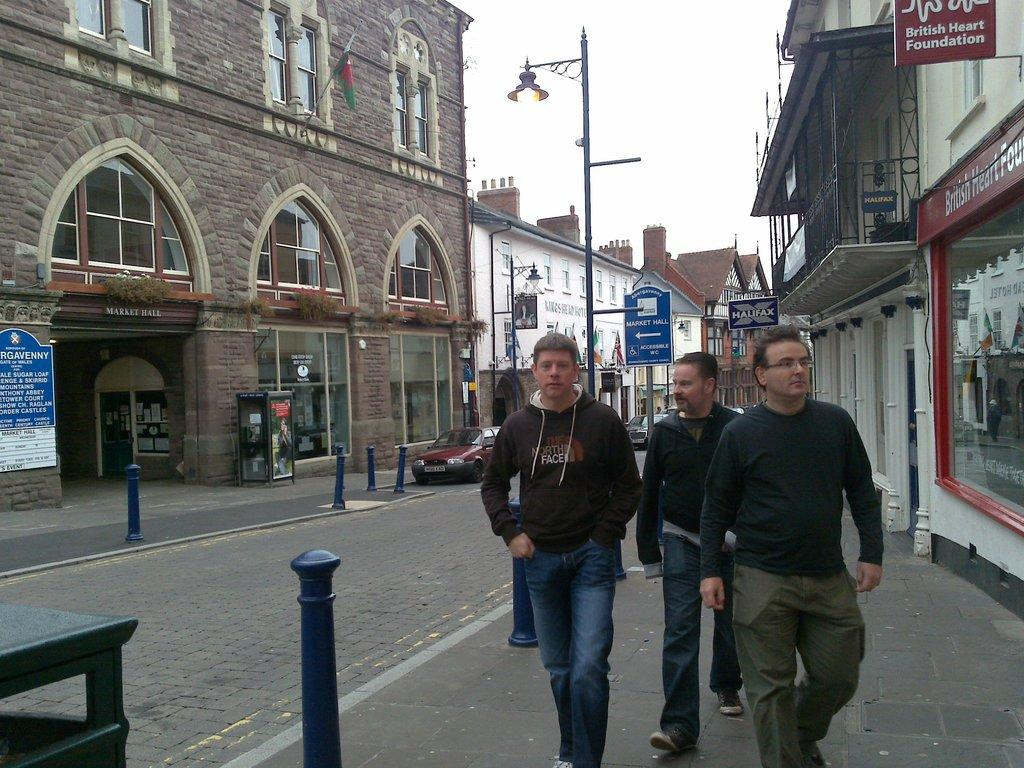What type of structures can be seen in the image? There are buildings with windows in the image. What objects are visible near the buildings? Boards and light poles are present in the image. What are the people in the image doing? People are walking on a footpath in the image. What can be seen in the background of the image? Vehicles are visible in the background of the image. What symbol is present in the image? There is a flag in the image. What type of winter clothing can be seen on the people in the image? There is no mention of winter or clothing in the image; people are simply walking on a footpath. What show is being performed in the image? There is no indication of a show or performance taking place in the image. 